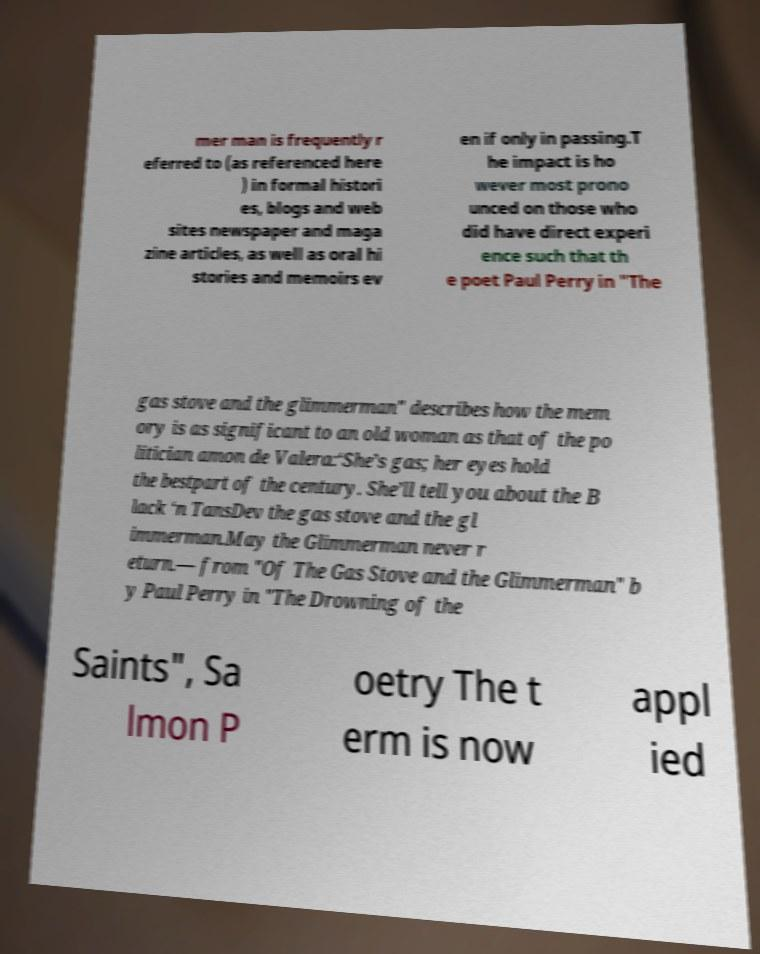Please identify and transcribe the text found in this image. mer man is frequently r eferred to (as referenced here ) in formal histori es, blogs and web sites newspaper and maga zine articles, as well as oral hi stories and memoirs ev en if only in passing.T he impact is ho wever most prono unced on those who did have direct experi ence such that th e poet Paul Perry in "The gas stove and the glimmerman" describes how the mem ory is as significant to an old woman as that of the po litician amon de Valera:‘She’s gas; her eyes hold the bestpart of the century. She’ll tell you about the B lack ‘n TansDev the gas stove and the gl immerman.May the Glimmerman never r eturn.— from "Of The Gas Stove and the Glimmerman" b y Paul Perry in "The Drowning of the Saints", Sa lmon P oetry The t erm is now appl ied 